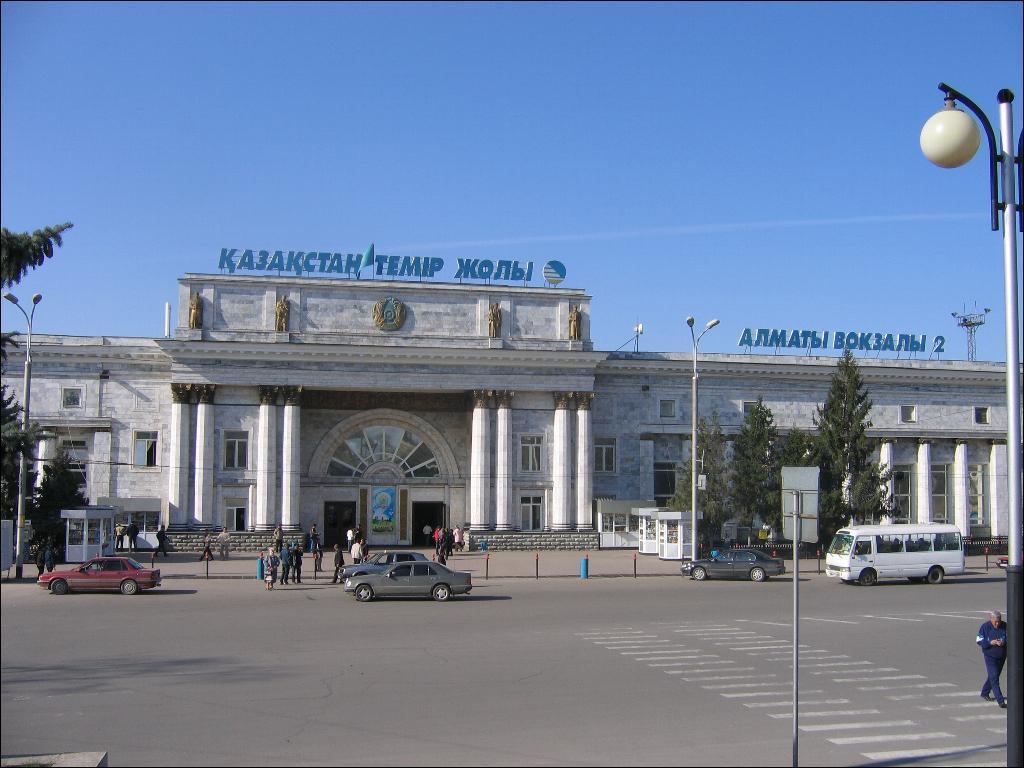Please provide a concise description of this image. In this picture I can see at the bottom few vehicles are moving on the road and there are few people, there are trees on either side of this image. In the middle it looks like a building, at the top there is the sky. 